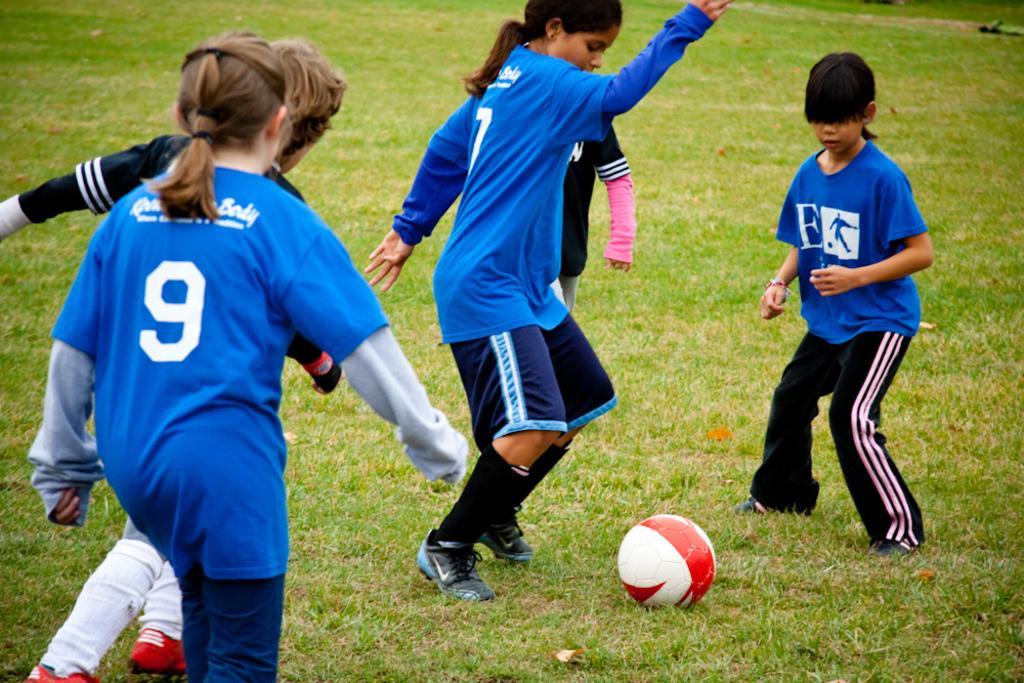Please provide a concise description of this image. This picture describes about group of people, they are playing game, in front of them we can see a ball on the grass. 